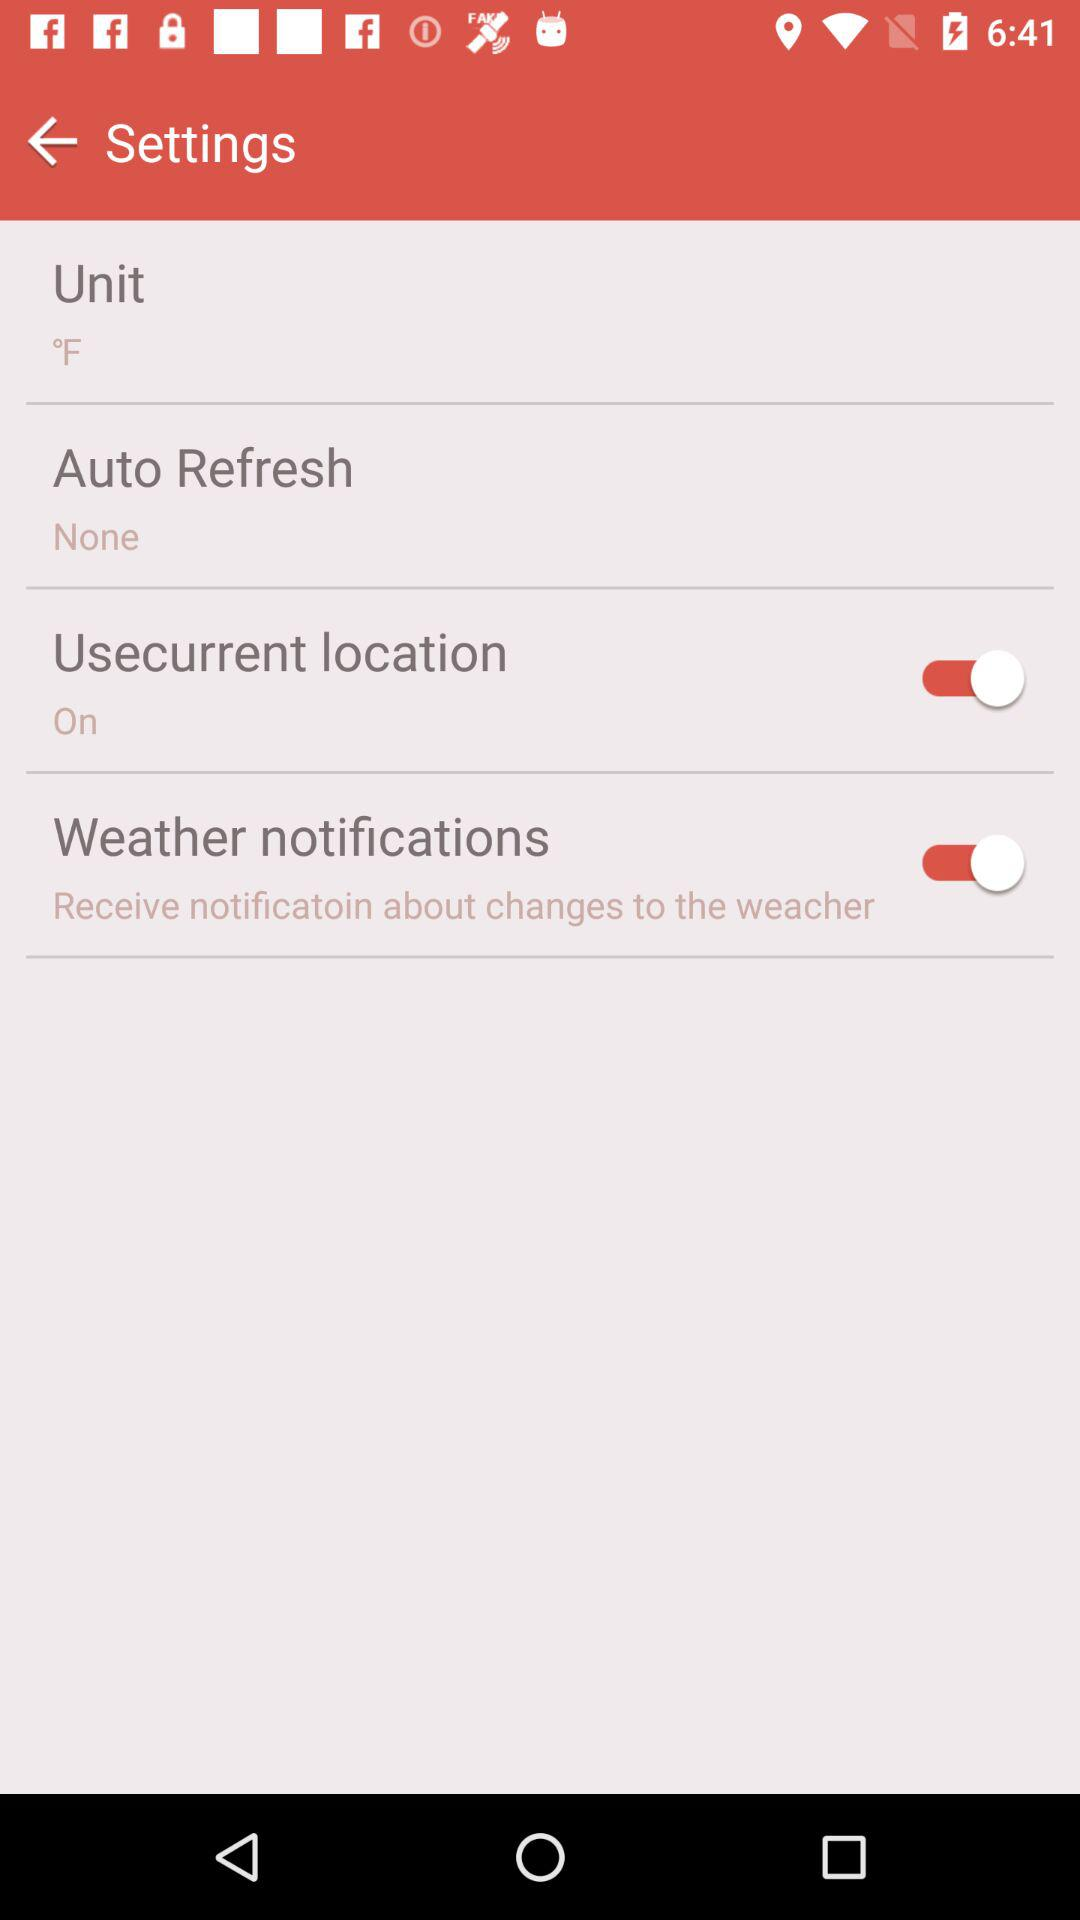How many items have a switch?
Answer the question using a single word or phrase. 2 